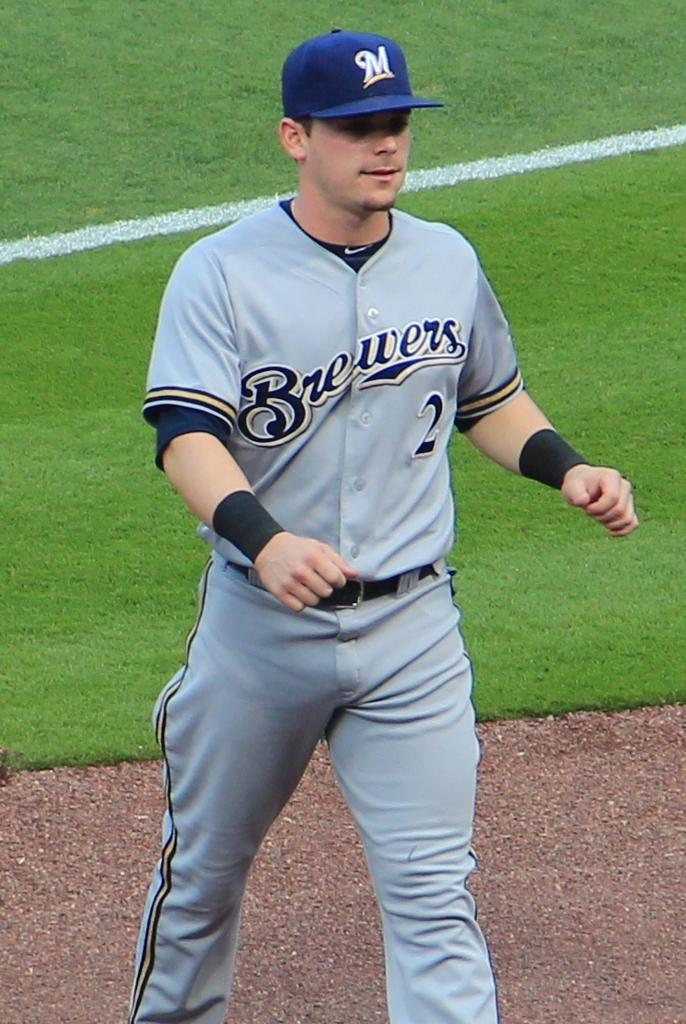<image>
Write a terse but informative summary of the picture. Baseball player wearing a jersery that says Brewers on it. 